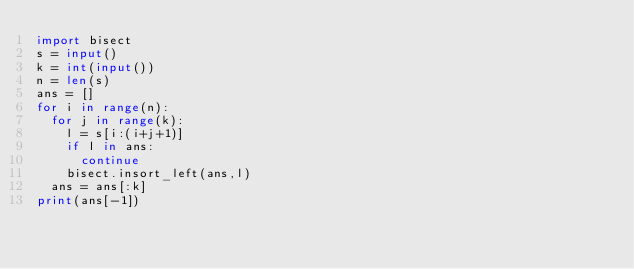<code> <loc_0><loc_0><loc_500><loc_500><_Python_>import bisect
s = input()
k = int(input())
n = len(s)
ans = []
for i in range(n):
  for j in range(k):
    l = s[i:(i+j+1)]
    if l in ans:
      continue
    bisect.insort_left(ans,l)
  ans = ans[:k]
print(ans[-1])</code> 